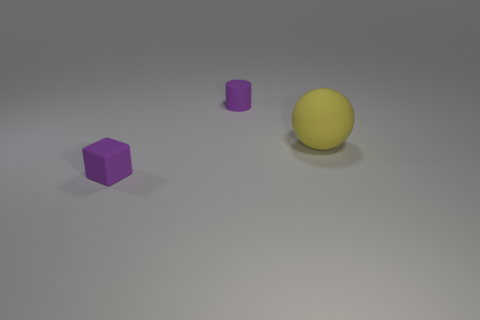Add 2 big cylinders. How many objects exist? 5 Subtract all cubes. How many objects are left? 2 Subtract all matte cylinders. Subtract all matte cylinders. How many objects are left? 1 Add 1 large yellow spheres. How many large yellow spheres are left? 2 Add 1 tiny purple blocks. How many tiny purple blocks exist? 2 Subtract 0 blue cylinders. How many objects are left? 3 